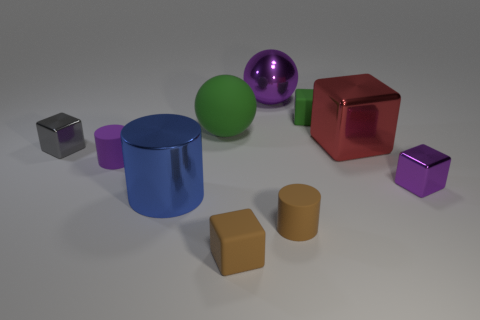Subtract all yellow blocks. Subtract all blue cylinders. How many blocks are left? 5 Subtract all balls. How many objects are left? 8 Subtract 0 blue blocks. How many objects are left? 10 Subtract all large yellow rubber cylinders. Subtract all metal spheres. How many objects are left? 9 Add 5 shiny cylinders. How many shiny cylinders are left? 6 Add 2 small matte cylinders. How many small matte cylinders exist? 4 